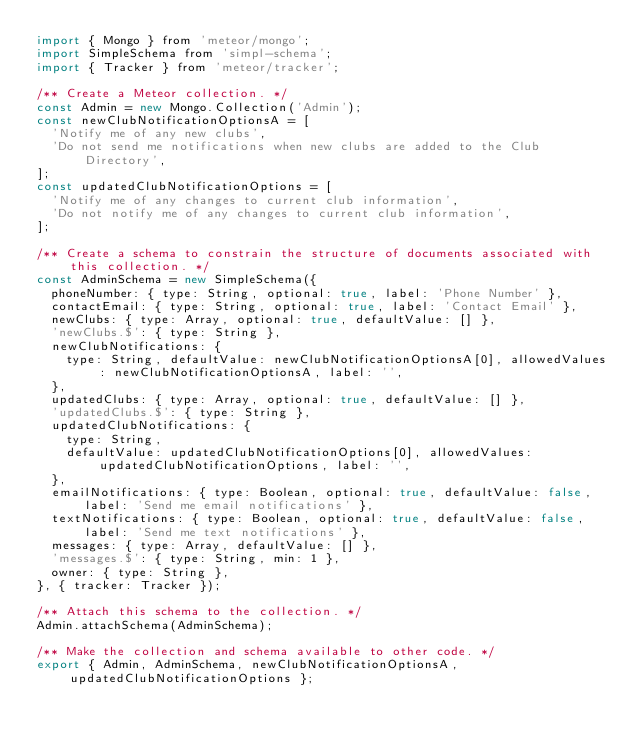Convert code to text. <code><loc_0><loc_0><loc_500><loc_500><_JavaScript_>import { Mongo } from 'meteor/mongo';
import SimpleSchema from 'simpl-schema';
import { Tracker } from 'meteor/tracker';

/** Create a Meteor collection. */
const Admin = new Mongo.Collection('Admin');
const newClubNotificationOptionsA = [
  'Notify me of any new clubs',
  'Do not send me notifications when new clubs are added to the Club Directory',
];
const updatedClubNotificationOptions = [
  'Notify me of any changes to current club information',
  'Do not notify me of any changes to current club information',
];

/** Create a schema to constrain the structure of documents associated with this collection. */
const AdminSchema = new SimpleSchema({
  phoneNumber: { type: String, optional: true, label: 'Phone Number' },
  contactEmail: { type: String, optional: true, label: 'Contact Email' },
  newClubs: { type: Array, optional: true, defaultValue: [] },
  'newClubs.$': { type: String },
  newClubNotifications: {
    type: String, defaultValue: newClubNotificationOptionsA[0], allowedValues: newClubNotificationOptionsA, label: '',
  },
  updatedClubs: { type: Array, optional: true, defaultValue: [] },
  'updatedClubs.$': { type: String },
  updatedClubNotifications: {
    type: String,
    defaultValue: updatedClubNotificationOptions[0], allowedValues: updatedClubNotificationOptions, label: '',
  },
  emailNotifications: { type: Boolean, optional: true, defaultValue: false, label: 'Send me email notifications' },
  textNotifications: { type: Boolean, optional: true, defaultValue: false, label: 'Send me text notifications' },
  messages: { type: Array, defaultValue: [] },
  'messages.$': { type: String, min: 1 },
  owner: { type: String },
}, { tracker: Tracker });

/** Attach this schema to the collection. */
Admin.attachSchema(AdminSchema);

/** Make the collection and schema available to other code. */
export { Admin, AdminSchema, newClubNotificationOptionsA, updatedClubNotificationOptions };
</code> 